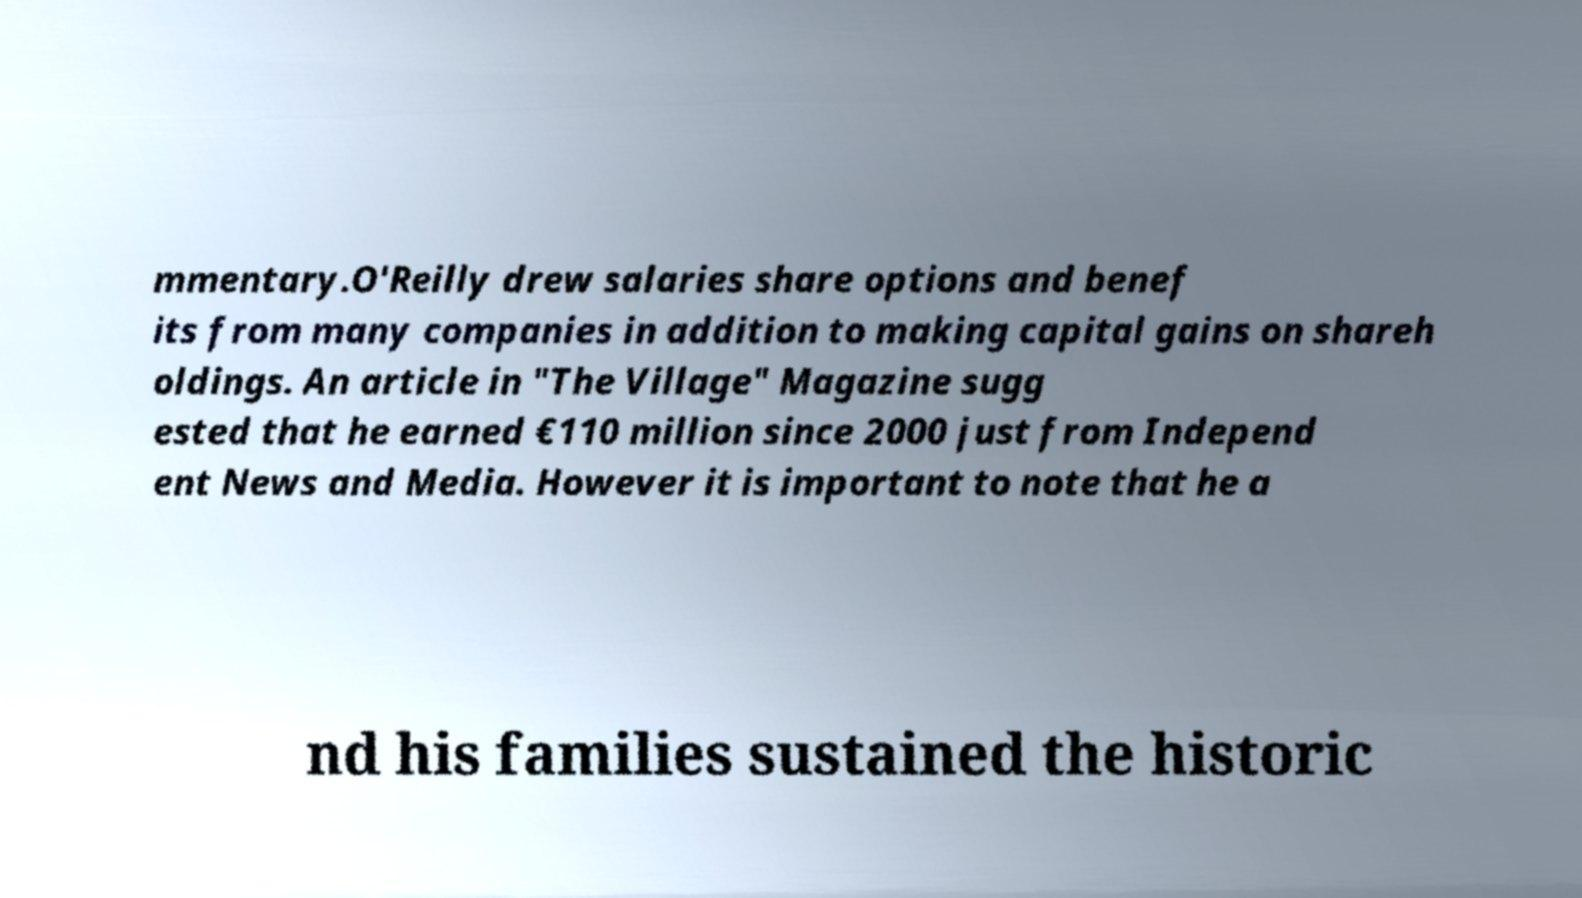What messages or text are displayed in this image? I need them in a readable, typed format. mmentary.O'Reilly drew salaries share options and benef its from many companies in addition to making capital gains on shareh oldings. An article in "The Village" Magazine sugg ested that he earned €110 million since 2000 just from Independ ent News and Media. However it is important to note that he a nd his families sustained the historic 